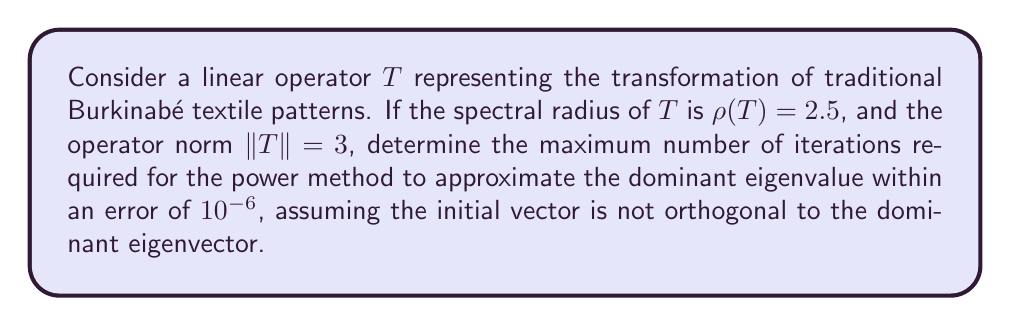Could you help me with this problem? To solve this problem, we'll use the convergence properties of the power method in spectral theory:

1) The power method converges to the dominant eigenvalue $\lambda_1$ (which equals the spectral radius $\rho(T)$ for normal operators) with a rate determined by $|\lambda_2/\lambda_1|$, where $\lambda_2$ is the second largest eigenvalue in magnitude.

2) We don't know $\lambda_2$, but we know that for any eigenvalue $\lambda$, $|\lambda| \leq \|T\|$. So, we can use $\|T\|$ as an upper bound for $|\lambda_2|$.

3) The error after $k$ iterations is approximately proportional to $|\lambda_2/\lambda_1|^k$.

4) We want to find $k$ such that $(\|T\|/\rho(T))^k \leq 10^{-6}$.

5) Taking logarithms:
   
   $$k \log(\|T\|/\rho(T)) \leq \log(10^{-6})$$

6) Solving for $k$:
   
   $$k \geq \frac{\log(10^{-6})}{\log(\|T\|/\rho(T))} = \frac{\log(10^{-6})}{\log(3/2.5)}$$

7) Calculate:
   
   $$k \geq \frac{-6 \log(10)}{\log(1.2)} \approx 31.55$$

8) Since $k$ must be an integer, we round up to the nearest whole number.

This analysis shows how spectral theory can be applied to study the convergence of algorithms used in analyzing Burkinabé cultural patterns, connecting mathematical concepts to cultural heritage preservation efforts that Luc Marius Ibriga might appreciate.
Answer: The maximum number of iterations required is 32. 